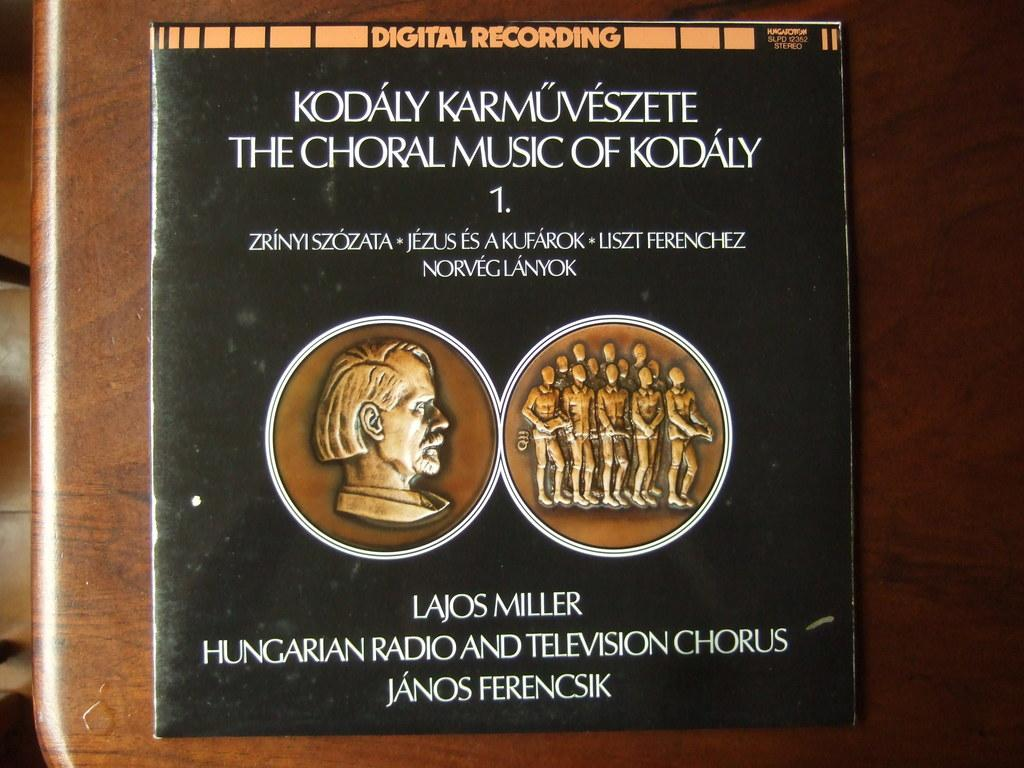<image>
Offer a succinct explanation of the picture presented. Digital recording of Kodaly Karmuveszete The Choral Music of Kodaly 